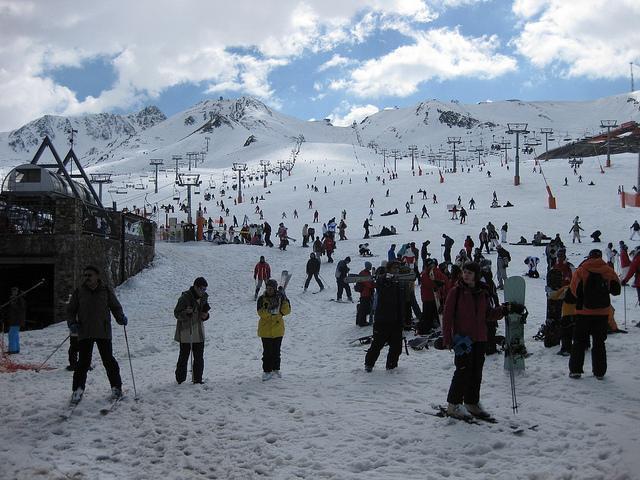How could someone near here gain elevation without expending a lot of energy?
Make your selection and explain in format: 'Answer: answer
Rationale: rationale.'
Options: Ski lift, jog, catch taxi, ski uphill. Answer: ski lift.
Rationale: They could use the ski lift to take them to the top of the hill. 